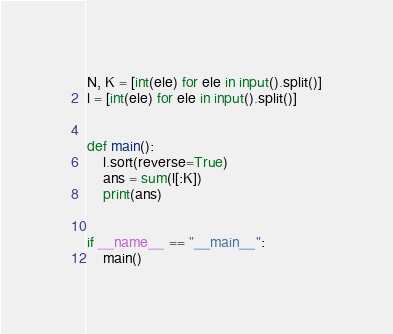<code> <loc_0><loc_0><loc_500><loc_500><_Python_>
N, K = [int(ele) for ele in input().split()]
l = [int(ele) for ele in input().split()]


def main():
    l.sort(reverse=True)
    ans = sum(l[:K])
    print(ans)


if __name__ == "__main__":
    main()
</code> 